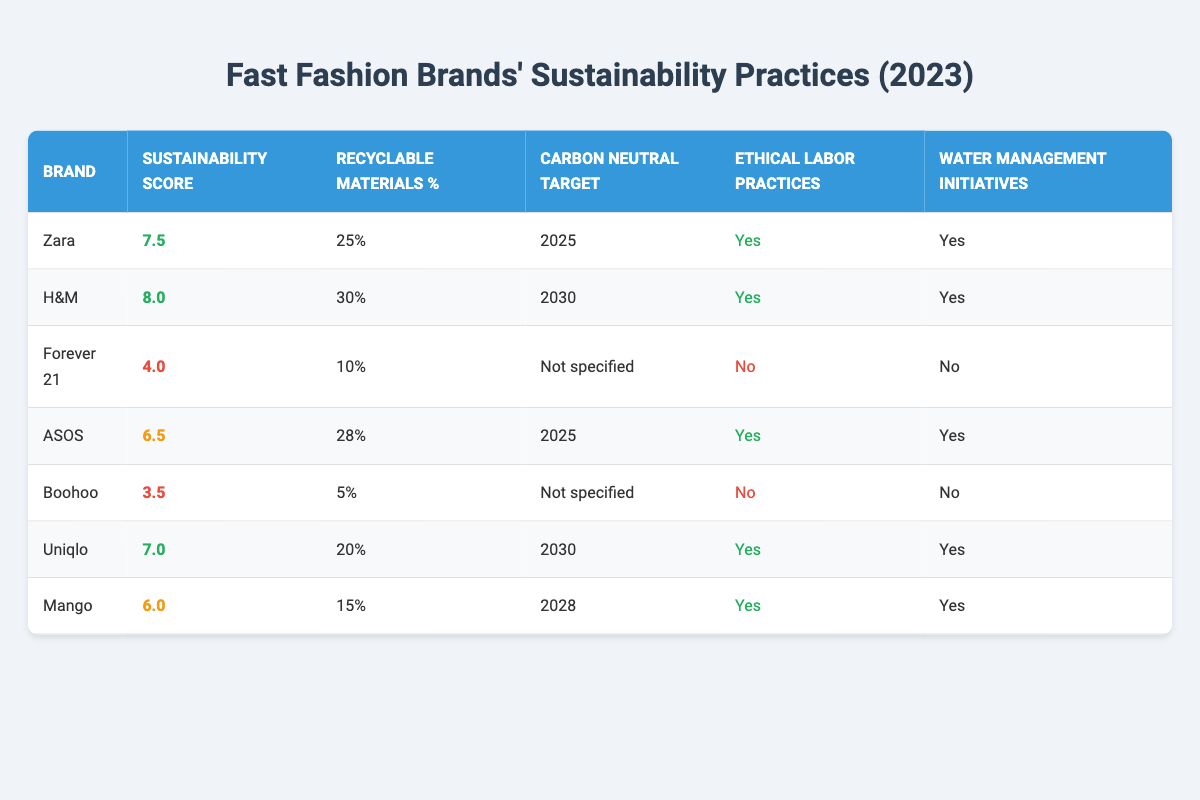What is the sustainability score of H&M? The table shows that H&M has a sustainability score listed as 8.0.
Answer: 8.0 Which brand has the highest percentage of recyclable materials? Looking at the percentage column, H&M has the highest percentage of recyclable materials at 30%.
Answer: H&M How many brands have ethical labor practices? The table indicates that Zara, H&M, ASOS, Uniqlo, and Mango have ethical labor practices, which totals to 5 brands.
Answer: 5 What is the carbon neutral target for Uniqlo? The table states that Uniqlo's carbon neutral target is set for 2030.
Answer: 2030 Which brand has the lowest sustainability score? Upon reviewing the sustainability scores in the table, Boohoo has the lowest sustainability score of 3.5.
Answer: Boohoo Is Forever 21 implementing water management initiatives? The table clearly states that Forever 21 does not have water management initiatives implemented, marked as 'No'.
Answer: No What is the average sustainability score of all the brands listed? First, the sustainability scores add up to 8.0 + 7.5 + 4.0 + 6.5 + 3.5 + 7.0 + 6.0 = 42.5. Since there are 7 brands, the average score is 42.5 / 7 = 6.07.
Answer: 6.07 Which brand has both ethical labor practices and a carbon neutral target by 2025? By examining the table, both Zara and ASOS fulfill these criteria, having ethical labor practices and a carbon neutral target set for 2025.
Answer: Zara and ASOS If we consider only brands with good sustainability scores, how many have set a carbon neutral target for 2030? The brands with a good sustainability score are H&M (8.0), Zara (7.5), and Uniqlo (7.0). Among these, Uniqlo and H&M have a carbon neutral target set for 2030, making it a total of 2 brands.
Answer: 2 What percentage of recyclable materials does Boohoo use, and how does it compare to the highest percentage? Boohoo uses 5% of recyclable materials. The highest percentage is held by H&M at 30%. To compare, Boohoo's 5% is 25% lower than H&M's 30%.
Answer: 25% lower than H&M 